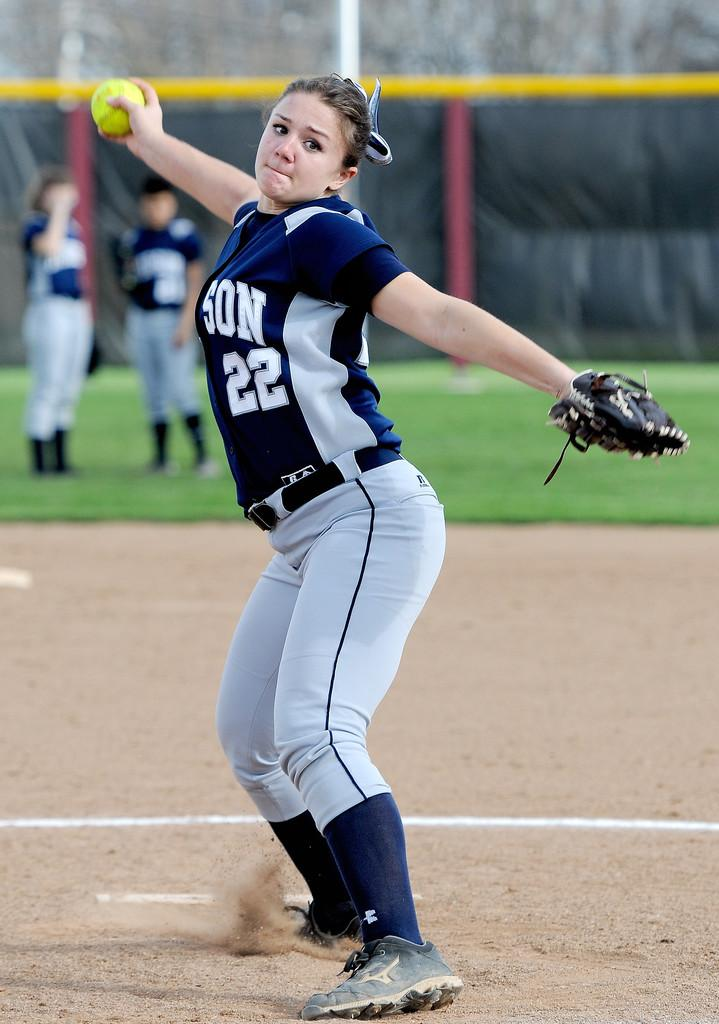<image>
Summarize the visual content of the image. a jersey that has the number 22 on it 